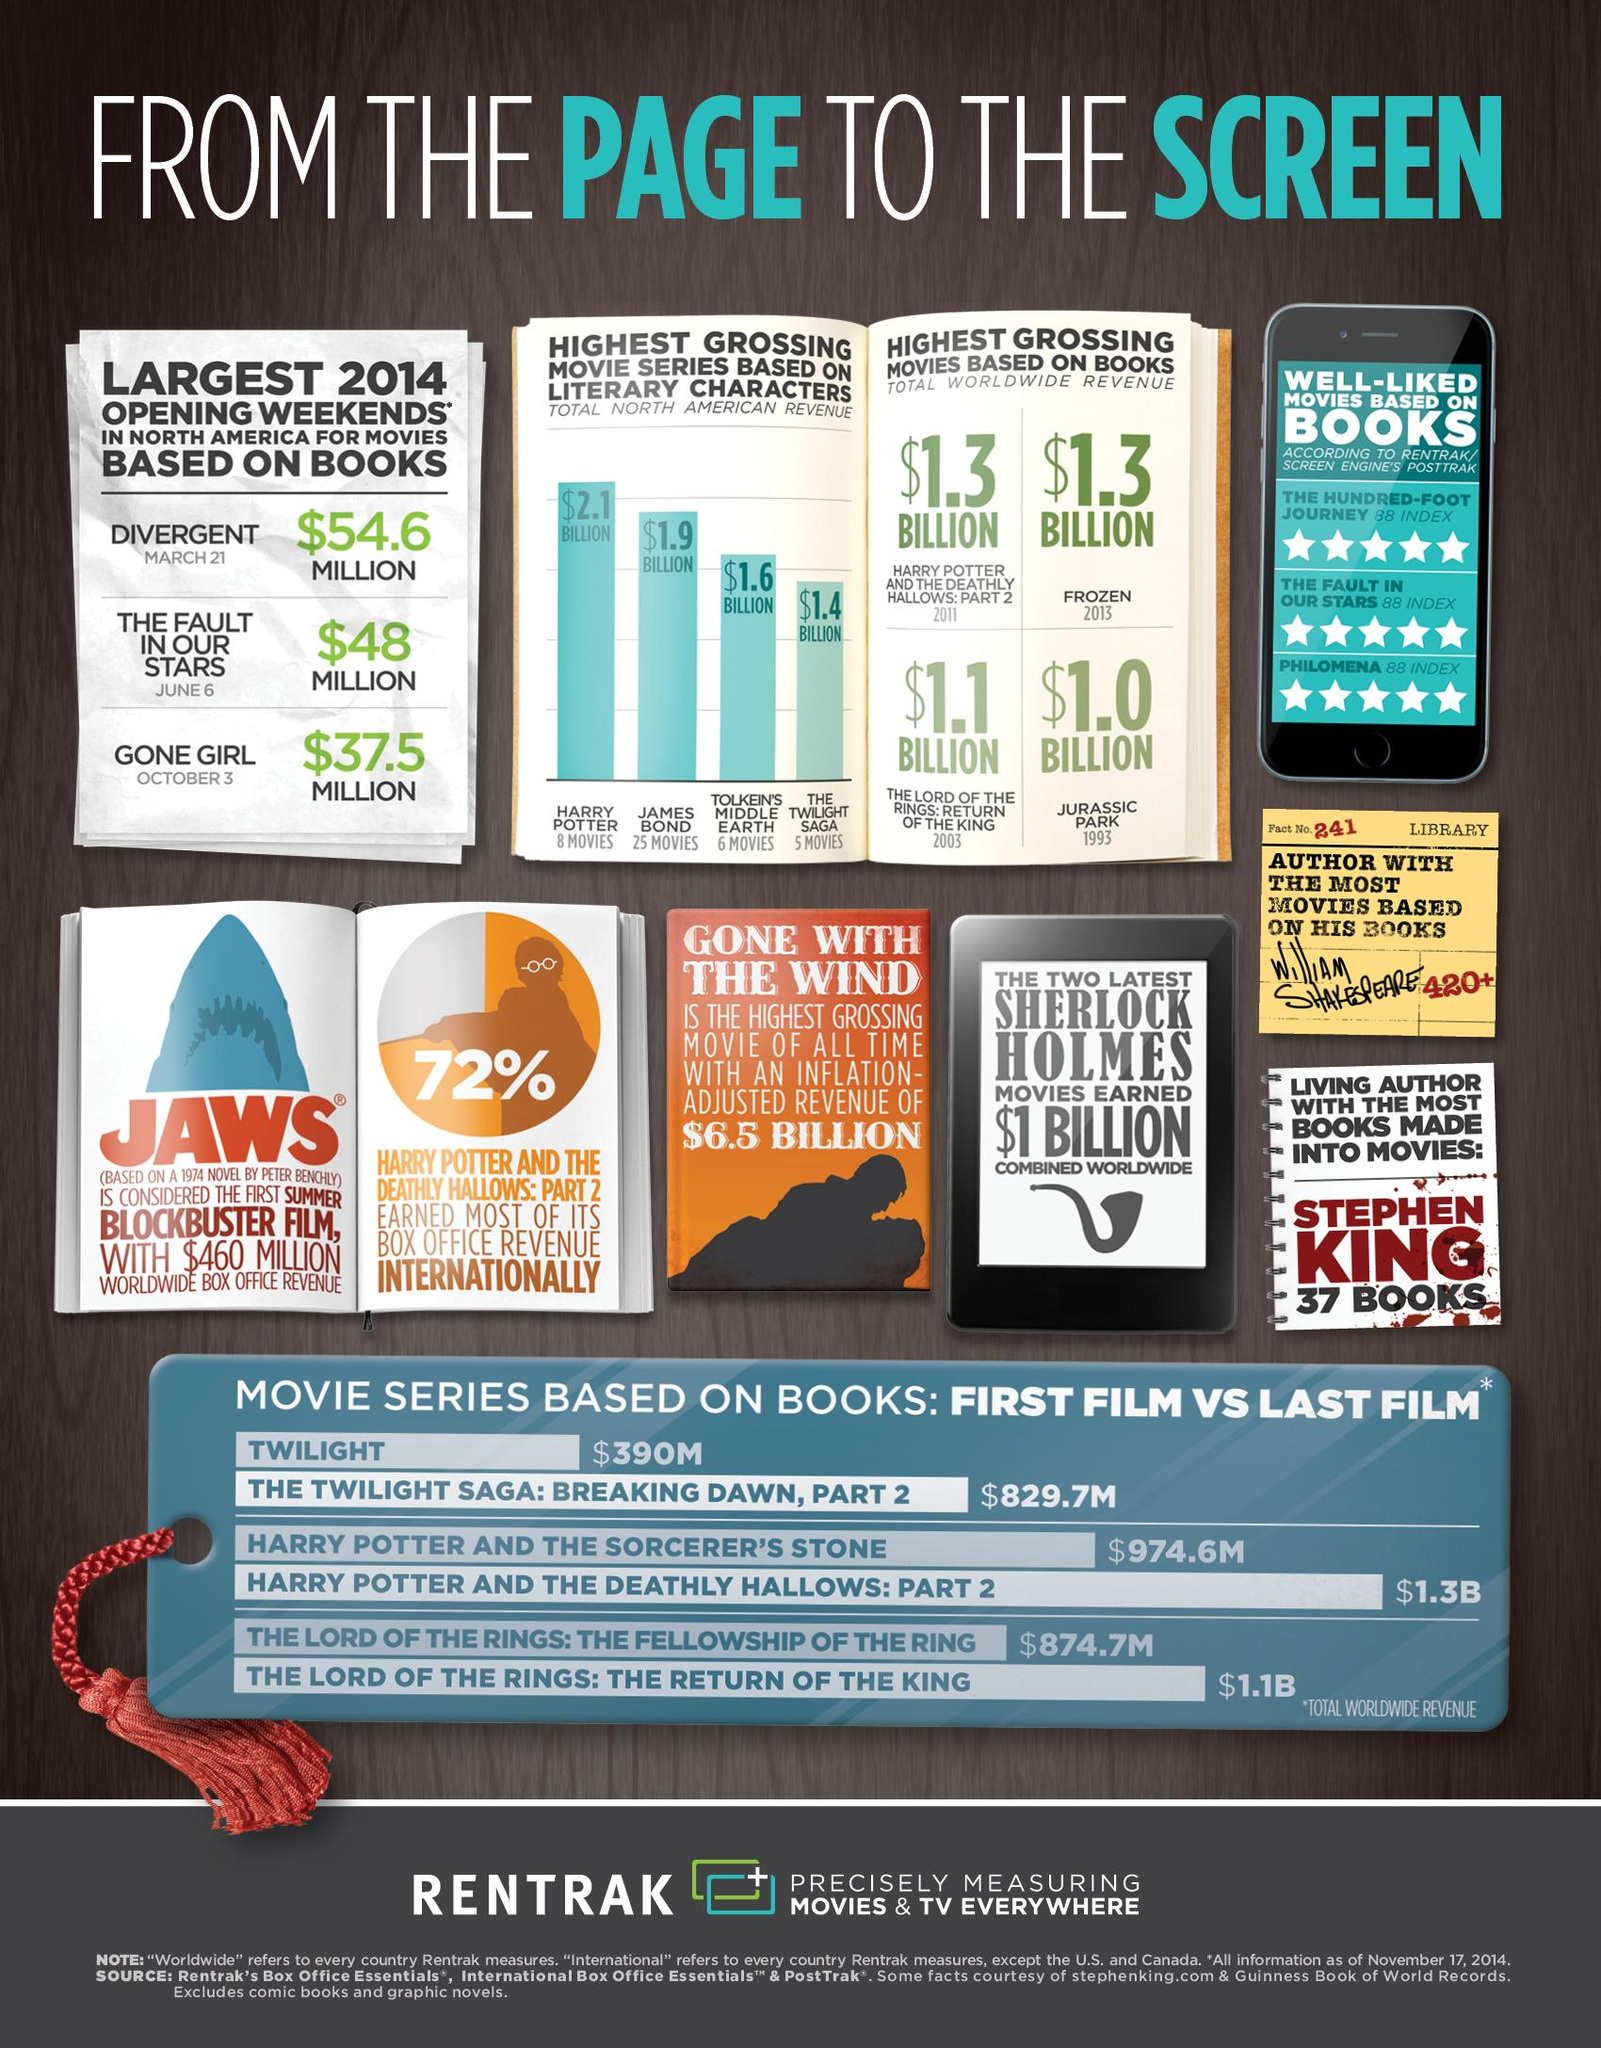List a handful of essential elements in this visual. Divergent was the movie that grossed the most during the opening weekends of 2014. According to Rentrak/Screen Engine's PostTrak, there are approximately three books that have an index of 88. James Bond's movie grossed more than Tolkien's Middle Earth. Both Harry Potter and the Deathly Hallows: Part 2 and Frozen have collectively grossed over $1.3 billion at the global box office. In 2014, the third highest grossing movie during its opening weekend was released in October. 